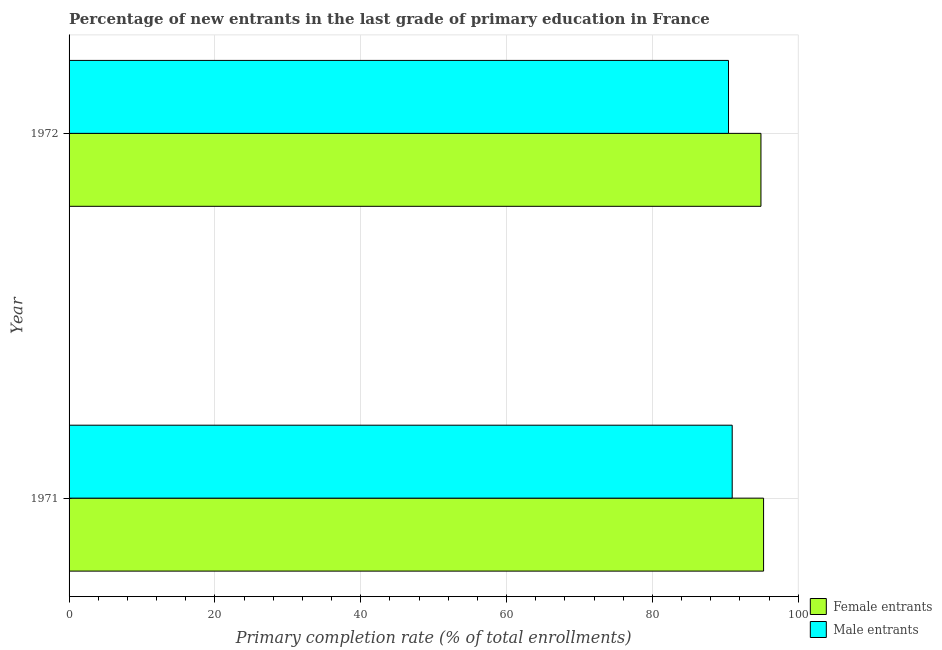How many groups of bars are there?
Provide a short and direct response. 2. Are the number of bars on each tick of the Y-axis equal?
Your answer should be compact. Yes. How many bars are there on the 1st tick from the bottom?
Your answer should be very brief. 2. In how many cases, is the number of bars for a given year not equal to the number of legend labels?
Offer a very short reply. 0. What is the primary completion rate of female entrants in 1971?
Offer a very short reply. 95.25. Across all years, what is the maximum primary completion rate of female entrants?
Your response must be concise. 95.25. Across all years, what is the minimum primary completion rate of male entrants?
Your answer should be compact. 90.44. What is the total primary completion rate of male entrants in the graph?
Make the answer very short. 181.39. What is the difference between the primary completion rate of female entrants in 1971 and that in 1972?
Provide a short and direct response. 0.36. What is the difference between the primary completion rate of male entrants in 1971 and the primary completion rate of female entrants in 1972?
Ensure brevity in your answer.  -3.94. What is the average primary completion rate of male entrants per year?
Your answer should be compact. 90.69. In the year 1971, what is the difference between the primary completion rate of female entrants and primary completion rate of male entrants?
Provide a succinct answer. 4.3. In how many years, is the primary completion rate of female entrants greater than 88 %?
Keep it short and to the point. 2. Is the primary completion rate of male entrants in 1971 less than that in 1972?
Provide a short and direct response. No. Is the difference between the primary completion rate of male entrants in 1971 and 1972 greater than the difference between the primary completion rate of female entrants in 1971 and 1972?
Offer a very short reply. Yes. In how many years, is the primary completion rate of female entrants greater than the average primary completion rate of female entrants taken over all years?
Provide a succinct answer. 1. What does the 2nd bar from the top in 1971 represents?
Offer a terse response. Female entrants. What does the 2nd bar from the bottom in 1971 represents?
Ensure brevity in your answer.  Male entrants. Are all the bars in the graph horizontal?
Ensure brevity in your answer.  Yes. Are the values on the major ticks of X-axis written in scientific E-notation?
Ensure brevity in your answer.  No. How many legend labels are there?
Provide a short and direct response. 2. What is the title of the graph?
Your answer should be compact. Percentage of new entrants in the last grade of primary education in France. What is the label or title of the X-axis?
Provide a short and direct response. Primary completion rate (% of total enrollments). What is the label or title of the Y-axis?
Make the answer very short. Year. What is the Primary completion rate (% of total enrollments) in Female entrants in 1971?
Provide a succinct answer. 95.25. What is the Primary completion rate (% of total enrollments) of Male entrants in 1971?
Ensure brevity in your answer.  90.95. What is the Primary completion rate (% of total enrollments) in Female entrants in 1972?
Provide a short and direct response. 94.89. What is the Primary completion rate (% of total enrollments) of Male entrants in 1972?
Ensure brevity in your answer.  90.44. Across all years, what is the maximum Primary completion rate (% of total enrollments) of Female entrants?
Provide a succinct answer. 95.25. Across all years, what is the maximum Primary completion rate (% of total enrollments) of Male entrants?
Your answer should be very brief. 90.95. Across all years, what is the minimum Primary completion rate (% of total enrollments) of Female entrants?
Offer a terse response. 94.89. Across all years, what is the minimum Primary completion rate (% of total enrollments) in Male entrants?
Provide a succinct answer. 90.44. What is the total Primary completion rate (% of total enrollments) in Female entrants in the graph?
Keep it short and to the point. 190.14. What is the total Primary completion rate (% of total enrollments) of Male entrants in the graph?
Ensure brevity in your answer.  181.39. What is the difference between the Primary completion rate (% of total enrollments) in Female entrants in 1971 and that in 1972?
Ensure brevity in your answer.  0.36. What is the difference between the Primary completion rate (% of total enrollments) in Male entrants in 1971 and that in 1972?
Provide a succinct answer. 0.51. What is the difference between the Primary completion rate (% of total enrollments) of Female entrants in 1971 and the Primary completion rate (% of total enrollments) of Male entrants in 1972?
Provide a short and direct response. 4.81. What is the average Primary completion rate (% of total enrollments) in Female entrants per year?
Provide a short and direct response. 95.07. What is the average Primary completion rate (% of total enrollments) in Male entrants per year?
Ensure brevity in your answer.  90.69. In the year 1971, what is the difference between the Primary completion rate (% of total enrollments) of Female entrants and Primary completion rate (% of total enrollments) of Male entrants?
Your answer should be very brief. 4.3. In the year 1972, what is the difference between the Primary completion rate (% of total enrollments) of Female entrants and Primary completion rate (% of total enrollments) of Male entrants?
Provide a succinct answer. 4.45. What is the ratio of the Primary completion rate (% of total enrollments) of Female entrants in 1971 to that in 1972?
Make the answer very short. 1. What is the ratio of the Primary completion rate (% of total enrollments) in Male entrants in 1971 to that in 1972?
Provide a succinct answer. 1.01. What is the difference between the highest and the second highest Primary completion rate (% of total enrollments) of Female entrants?
Give a very brief answer. 0.36. What is the difference between the highest and the second highest Primary completion rate (% of total enrollments) of Male entrants?
Give a very brief answer. 0.51. What is the difference between the highest and the lowest Primary completion rate (% of total enrollments) in Female entrants?
Offer a very short reply. 0.36. What is the difference between the highest and the lowest Primary completion rate (% of total enrollments) of Male entrants?
Your answer should be very brief. 0.51. 